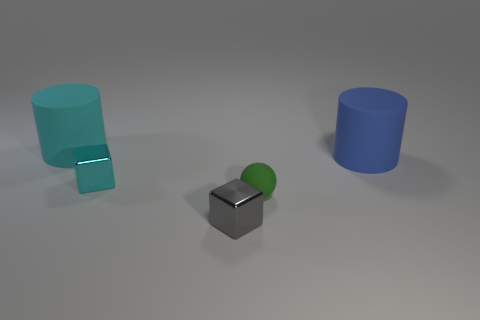What shape is the rubber object that is the same size as the cyan cube?
Provide a succinct answer. Sphere. The green rubber object is what size?
Your response must be concise. Small. There is a large cylinder right of the big rubber thing left of the large rubber object that is to the right of the tiny sphere; what is it made of?
Keep it short and to the point. Rubber. There is another cylinder that is the same material as the large blue cylinder; what is its color?
Offer a terse response. Cyan. There is a cylinder that is in front of the thing that is left of the small cyan cube; what number of gray cubes are on the right side of it?
Give a very brief answer. 0. Is there any other thing that has the same shape as the gray metallic thing?
Provide a short and direct response. Yes. How many objects are shiny blocks left of the gray metal block or tiny purple cylinders?
Ensure brevity in your answer.  1. Do the large cylinder to the right of the cyan shiny block and the small matte ball have the same color?
Ensure brevity in your answer.  No. What is the shape of the cyan metal thing behind the tiny metallic block in front of the tiny cyan thing?
Your response must be concise. Cube. Is the number of tiny metallic things to the right of the sphere less than the number of small green balls left of the tiny cyan metal cube?
Offer a terse response. No. 